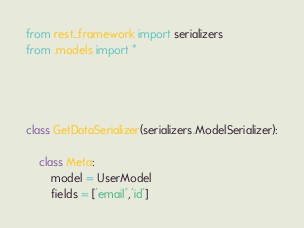Convert code to text. <code><loc_0><loc_0><loc_500><loc_500><_Python_>from rest_framework import serializers
from .models import *




class GetDataSerializer(serializers.ModelSerializer):
   
    class Meta:
        model = UserModel
        fields = ['email','id']
</code> 